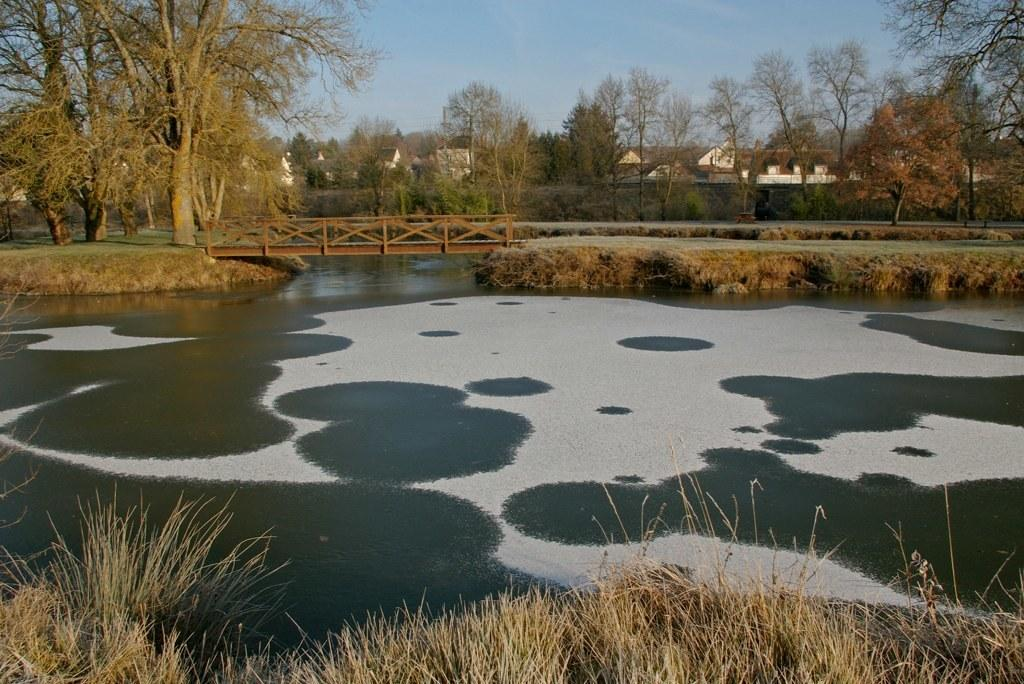What is one of the natural elements present in the image? There is water in the image. What type of vegetation can be seen in the image? There is grass in the image. What structure is present in the image? There is a bridge in the image. What can be seen in the background of the image? There are trees, houses, and the sky visible in the background of the image. What color are the eyes of the person holding the knife in the image? There is no person holding a knife in the image; it only features water, grass, a bridge, trees, houses, and the sky. 